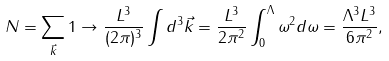Convert formula to latex. <formula><loc_0><loc_0><loc_500><loc_500>N = \sum _ { \vec { k } } 1 \rightarrow \frac { L ^ { 3 } } { ( 2 \pi ) ^ { 3 } } \int d ^ { 3 } \vec { k } = \frac { L ^ { 3 } } { 2 \pi ^ { 2 } } \int _ { 0 } ^ { \Lambda } \omega ^ { 2 } d \omega = \frac { \Lambda ^ { 3 } L ^ { 3 } } { 6 \pi ^ { 2 } } ,</formula> 